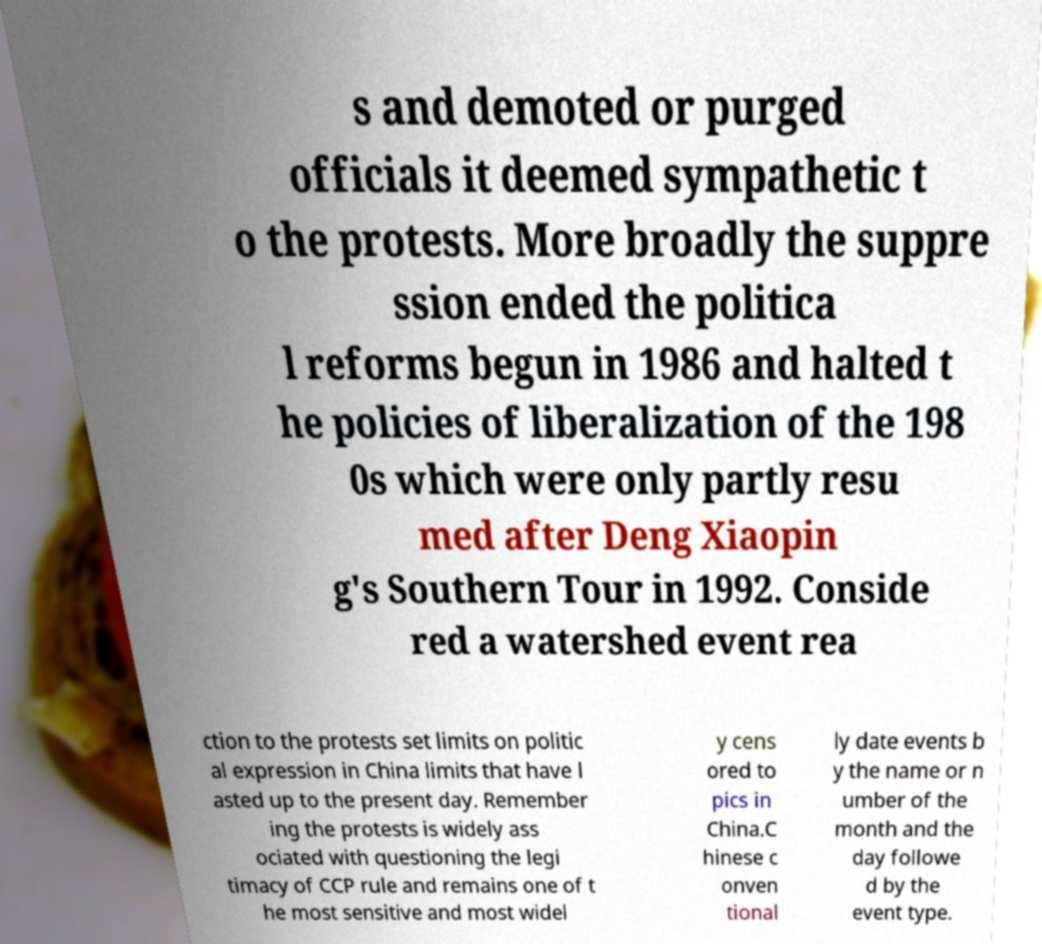Please read and relay the text visible in this image. What does it say? s and demoted or purged officials it deemed sympathetic t o the protests. More broadly the suppre ssion ended the politica l reforms begun in 1986 and halted t he policies of liberalization of the 198 0s which were only partly resu med after Deng Xiaopin g's Southern Tour in 1992. Conside red a watershed event rea ction to the protests set limits on politic al expression in China limits that have l asted up to the present day. Remember ing the protests is widely ass ociated with questioning the legi timacy of CCP rule and remains one of t he most sensitive and most widel y cens ored to pics in China.C hinese c onven tional ly date events b y the name or n umber of the month and the day followe d by the event type. 